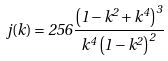<formula> <loc_0><loc_0><loc_500><loc_500>j ( k ) = 2 5 6 { \frac { \left ( 1 - { k } ^ { 2 } + { k } ^ { 4 } \right ) ^ { 3 } } { k ^ { 4 } \left ( 1 - k ^ { 2 } \right ) ^ { 2 } } }</formula> 